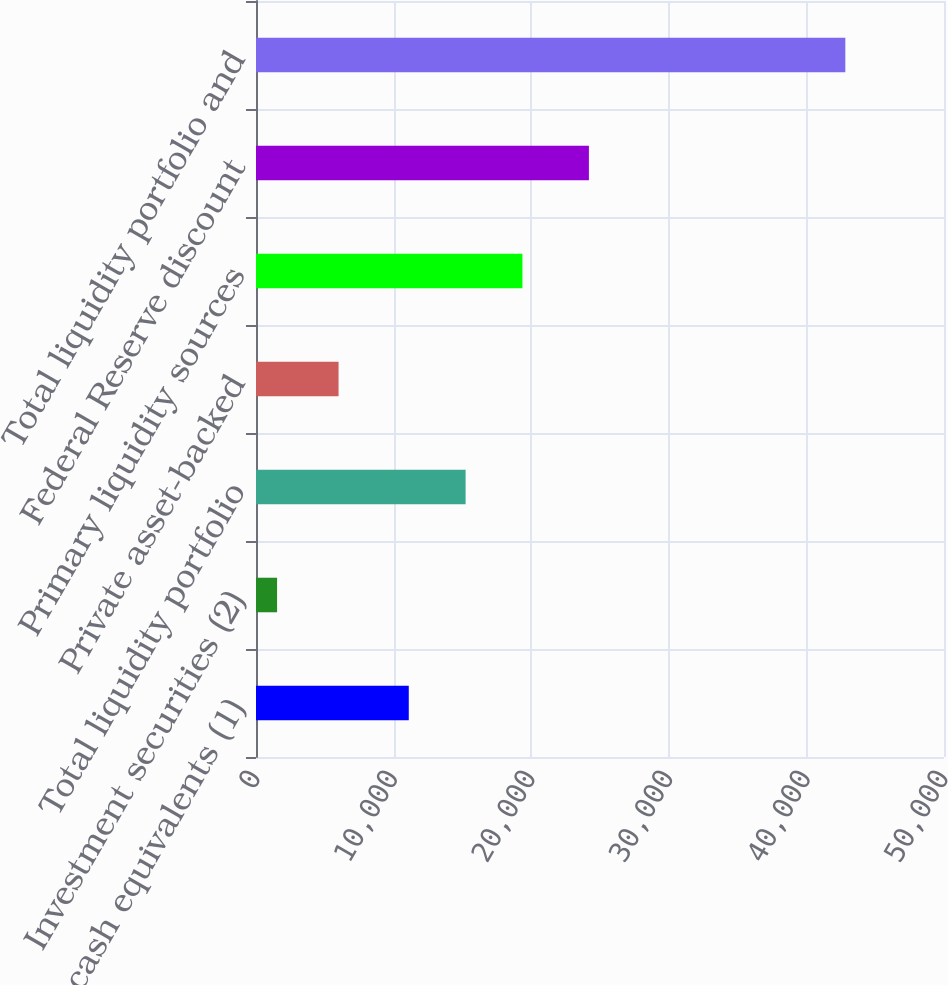<chart> <loc_0><loc_0><loc_500><loc_500><bar_chart><fcel>Cash and cash equivalents (1)<fcel>Investment securities (2)<fcel>Total liquidity portfolio<fcel>Private asset-backed<fcel>Primary liquidity sources<fcel>Federal Reserve discount<fcel>Total liquidity portfolio and<nl><fcel>11103<fcel>1532<fcel>15232.7<fcel>6000<fcel>19362.4<fcel>24194<fcel>42829<nl></chart> 